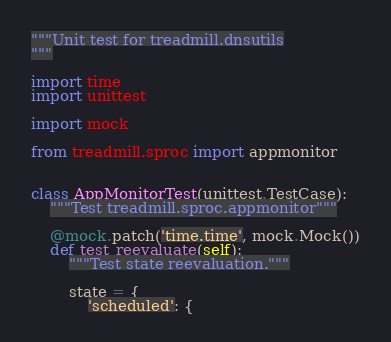<code> <loc_0><loc_0><loc_500><loc_500><_Python_>"""Unit test for treadmill.dnsutils
"""

import time
import unittest

import mock

from treadmill.sproc import appmonitor


class AppMonitorTest(unittest.TestCase):
    """Test treadmill.sproc.appmonitor"""

    @mock.patch('time.time', mock.Mock())
    def test_reevaluate(self):
        """Test state reevaluation."""

        state = {
            'scheduled': {</code> 